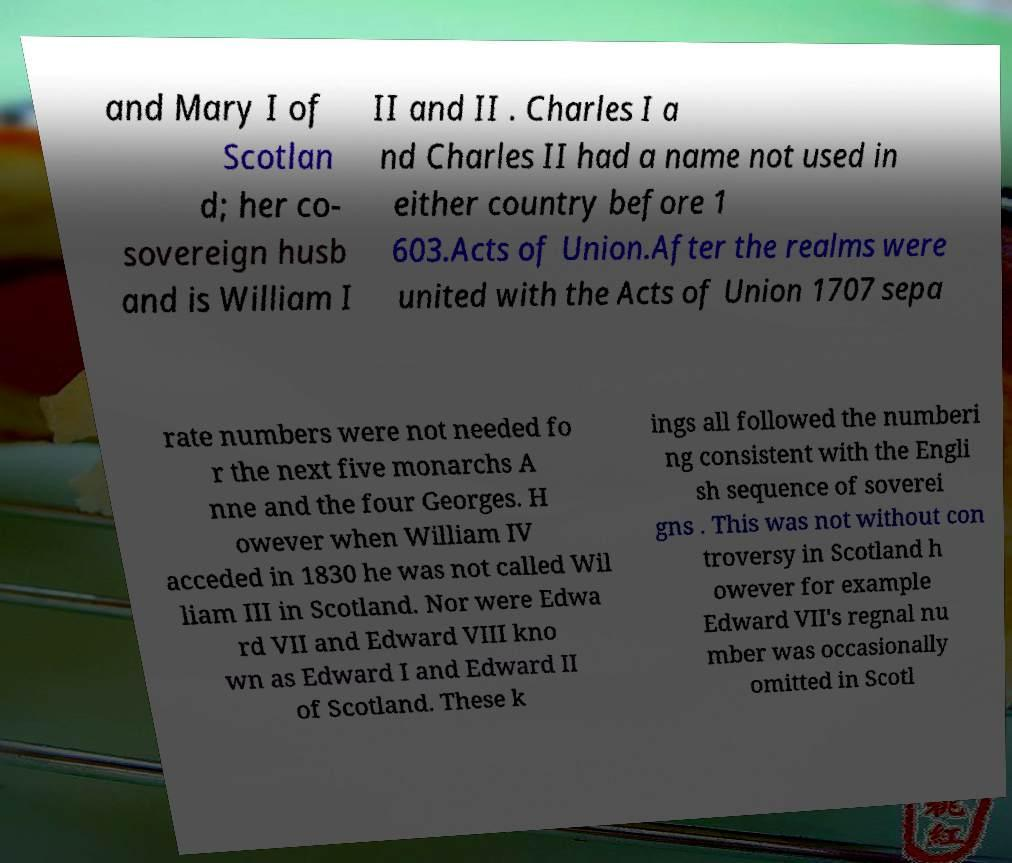Please identify and transcribe the text found in this image. and Mary I of Scotlan d; her co- sovereign husb and is William I II and II . Charles I a nd Charles II had a name not used in either country before 1 603.Acts of Union.After the realms were united with the Acts of Union 1707 sepa rate numbers were not needed fo r the next five monarchs A nne and the four Georges. H owever when William IV acceded in 1830 he was not called Wil liam III in Scotland. Nor were Edwa rd VII and Edward VIII kno wn as Edward I and Edward II of Scotland. These k ings all followed the numberi ng consistent with the Engli sh sequence of soverei gns . This was not without con troversy in Scotland h owever for example Edward VII's regnal nu mber was occasionally omitted in Scotl 